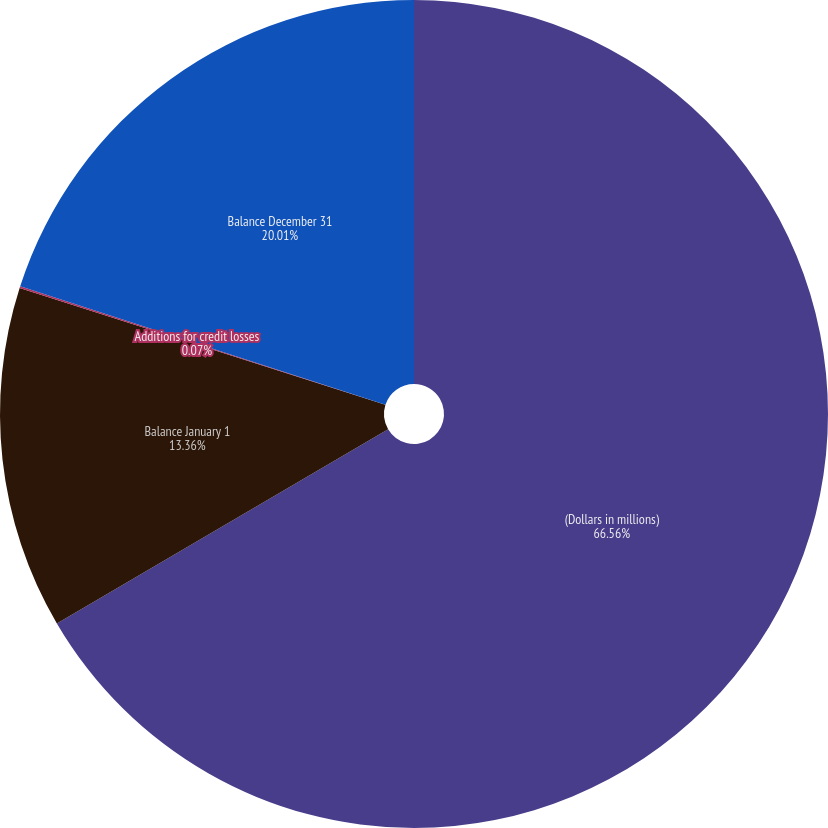Convert chart to OTSL. <chart><loc_0><loc_0><loc_500><loc_500><pie_chart><fcel>(Dollars in millions)<fcel>Balance January 1<fcel>Additions for credit losses<fcel>Balance December 31<nl><fcel>66.56%<fcel>13.36%<fcel>0.07%<fcel>20.01%<nl></chart> 